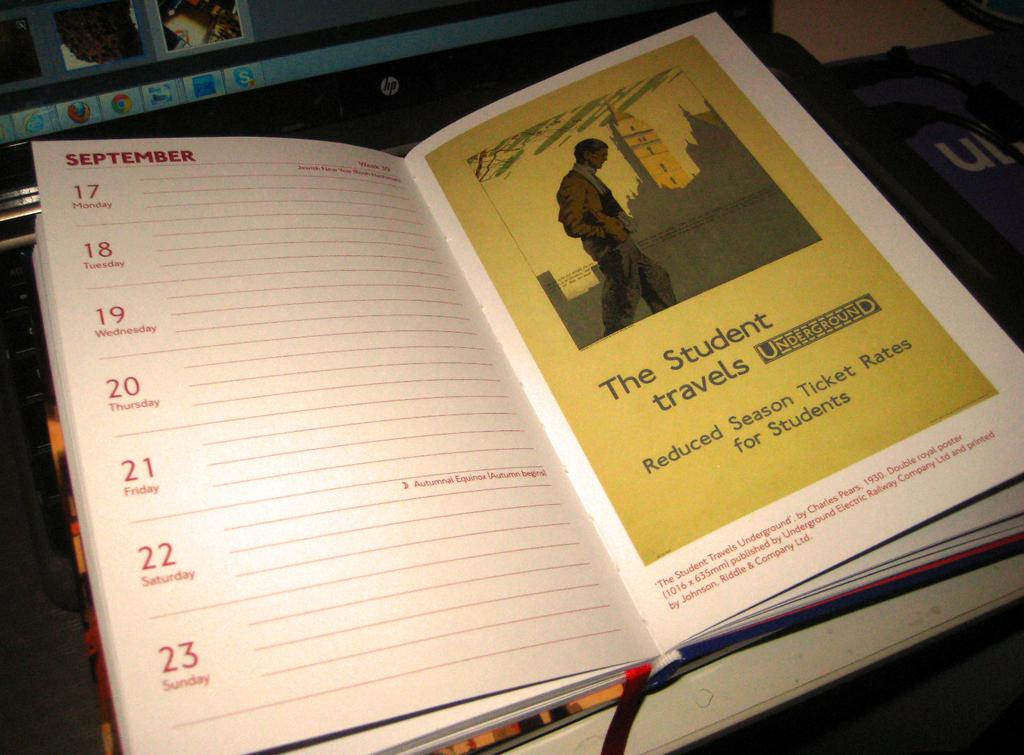<image>
Describe the image concisely. Calendar with a yellow page for "The Student Travels" showing a man looking down and walking. 